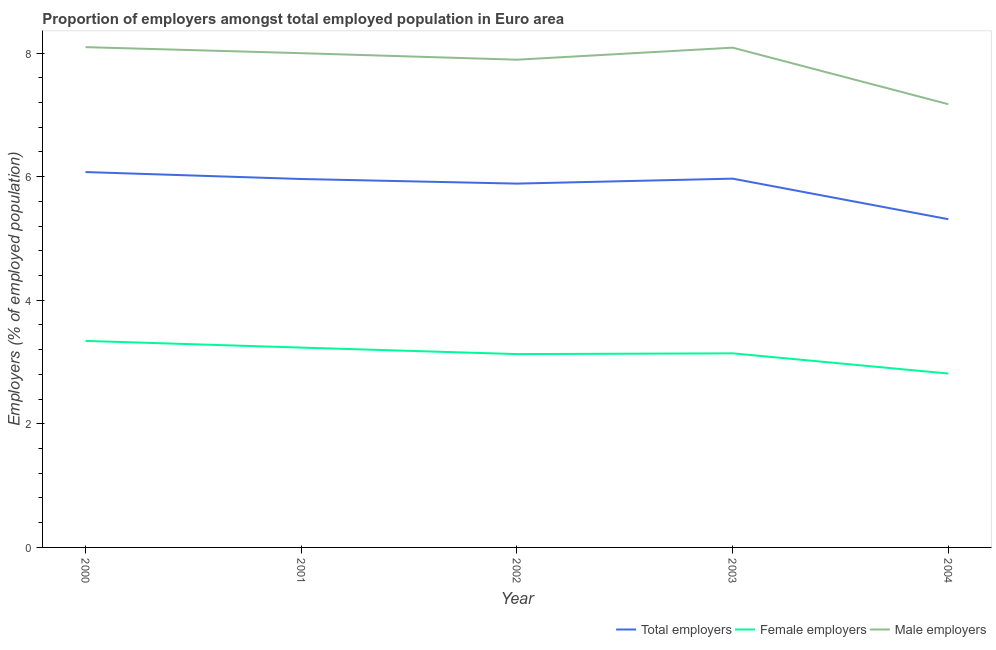How many different coloured lines are there?
Give a very brief answer. 3. Is the number of lines equal to the number of legend labels?
Make the answer very short. Yes. What is the percentage of male employers in 2001?
Offer a very short reply. 8. Across all years, what is the maximum percentage of male employers?
Ensure brevity in your answer.  8.1. Across all years, what is the minimum percentage of female employers?
Keep it short and to the point. 2.81. What is the total percentage of female employers in the graph?
Ensure brevity in your answer.  15.66. What is the difference between the percentage of total employers in 2001 and that in 2002?
Keep it short and to the point. 0.07. What is the difference between the percentage of male employers in 2001 and the percentage of female employers in 2003?
Your answer should be compact. 4.86. What is the average percentage of male employers per year?
Offer a terse response. 7.85. In the year 2004, what is the difference between the percentage of male employers and percentage of female employers?
Keep it short and to the point. 4.36. In how many years, is the percentage of male employers greater than 0.8 %?
Your answer should be compact. 5. What is the ratio of the percentage of total employers in 2000 to that in 2002?
Offer a very short reply. 1.03. Is the difference between the percentage of total employers in 2000 and 2002 greater than the difference between the percentage of female employers in 2000 and 2002?
Provide a short and direct response. No. What is the difference between the highest and the second highest percentage of total employers?
Provide a short and direct response. 0.11. What is the difference between the highest and the lowest percentage of male employers?
Your answer should be compact. 0.92. In how many years, is the percentage of male employers greater than the average percentage of male employers taken over all years?
Provide a succinct answer. 4. Is the percentage of total employers strictly greater than the percentage of male employers over the years?
Ensure brevity in your answer.  No. How many lines are there?
Your response must be concise. 3. How many years are there in the graph?
Offer a very short reply. 5. What is the difference between two consecutive major ticks on the Y-axis?
Offer a very short reply. 2. Are the values on the major ticks of Y-axis written in scientific E-notation?
Give a very brief answer. No. Does the graph contain any zero values?
Keep it short and to the point. No. How are the legend labels stacked?
Your response must be concise. Horizontal. What is the title of the graph?
Offer a very short reply. Proportion of employers amongst total employed population in Euro area. What is the label or title of the X-axis?
Give a very brief answer. Year. What is the label or title of the Y-axis?
Provide a short and direct response. Employers (% of employed population). What is the Employers (% of employed population) of Total employers in 2000?
Offer a terse response. 6.07. What is the Employers (% of employed population) in Female employers in 2000?
Your answer should be compact. 3.34. What is the Employers (% of employed population) in Male employers in 2000?
Offer a very short reply. 8.1. What is the Employers (% of employed population) of Total employers in 2001?
Offer a terse response. 5.96. What is the Employers (% of employed population) in Female employers in 2001?
Ensure brevity in your answer.  3.23. What is the Employers (% of employed population) of Male employers in 2001?
Offer a terse response. 8. What is the Employers (% of employed population) of Total employers in 2002?
Offer a very short reply. 5.89. What is the Employers (% of employed population) of Female employers in 2002?
Your answer should be compact. 3.13. What is the Employers (% of employed population) in Male employers in 2002?
Make the answer very short. 7.89. What is the Employers (% of employed population) in Total employers in 2003?
Offer a very short reply. 5.97. What is the Employers (% of employed population) of Female employers in 2003?
Give a very brief answer. 3.14. What is the Employers (% of employed population) in Male employers in 2003?
Offer a terse response. 8.09. What is the Employers (% of employed population) in Total employers in 2004?
Give a very brief answer. 5.31. What is the Employers (% of employed population) of Female employers in 2004?
Offer a very short reply. 2.81. What is the Employers (% of employed population) of Male employers in 2004?
Your answer should be compact. 7.17. Across all years, what is the maximum Employers (% of employed population) of Total employers?
Make the answer very short. 6.07. Across all years, what is the maximum Employers (% of employed population) of Female employers?
Your answer should be very brief. 3.34. Across all years, what is the maximum Employers (% of employed population) of Male employers?
Give a very brief answer. 8.1. Across all years, what is the minimum Employers (% of employed population) of Total employers?
Make the answer very short. 5.31. Across all years, what is the minimum Employers (% of employed population) in Female employers?
Give a very brief answer. 2.81. Across all years, what is the minimum Employers (% of employed population) of Male employers?
Make the answer very short. 7.17. What is the total Employers (% of employed population) in Total employers in the graph?
Your response must be concise. 29.2. What is the total Employers (% of employed population) in Female employers in the graph?
Offer a terse response. 15.66. What is the total Employers (% of employed population) of Male employers in the graph?
Keep it short and to the point. 39.25. What is the difference between the Employers (% of employed population) of Total employers in 2000 and that in 2001?
Keep it short and to the point. 0.11. What is the difference between the Employers (% of employed population) in Female employers in 2000 and that in 2001?
Your answer should be compact. 0.11. What is the difference between the Employers (% of employed population) of Male employers in 2000 and that in 2001?
Offer a terse response. 0.1. What is the difference between the Employers (% of employed population) in Total employers in 2000 and that in 2002?
Keep it short and to the point. 0.19. What is the difference between the Employers (% of employed population) of Female employers in 2000 and that in 2002?
Offer a very short reply. 0.21. What is the difference between the Employers (% of employed population) in Male employers in 2000 and that in 2002?
Provide a short and direct response. 0.2. What is the difference between the Employers (% of employed population) in Total employers in 2000 and that in 2003?
Keep it short and to the point. 0.11. What is the difference between the Employers (% of employed population) in Female employers in 2000 and that in 2003?
Give a very brief answer. 0.2. What is the difference between the Employers (% of employed population) in Male employers in 2000 and that in 2003?
Your answer should be very brief. 0.01. What is the difference between the Employers (% of employed population) of Total employers in 2000 and that in 2004?
Make the answer very short. 0.76. What is the difference between the Employers (% of employed population) of Female employers in 2000 and that in 2004?
Your answer should be compact. 0.53. What is the difference between the Employers (% of employed population) of Male employers in 2000 and that in 2004?
Make the answer very short. 0.92. What is the difference between the Employers (% of employed population) of Total employers in 2001 and that in 2002?
Provide a short and direct response. 0.07. What is the difference between the Employers (% of employed population) of Female employers in 2001 and that in 2002?
Provide a succinct answer. 0.11. What is the difference between the Employers (% of employed population) in Male employers in 2001 and that in 2002?
Offer a very short reply. 0.11. What is the difference between the Employers (% of employed population) of Total employers in 2001 and that in 2003?
Your answer should be compact. -0.01. What is the difference between the Employers (% of employed population) of Female employers in 2001 and that in 2003?
Make the answer very short. 0.09. What is the difference between the Employers (% of employed population) of Male employers in 2001 and that in 2003?
Keep it short and to the point. -0.09. What is the difference between the Employers (% of employed population) in Total employers in 2001 and that in 2004?
Keep it short and to the point. 0.65. What is the difference between the Employers (% of employed population) of Female employers in 2001 and that in 2004?
Make the answer very short. 0.42. What is the difference between the Employers (% of employed population) in Male employers in 2001 and that in 2004?
Offer a very short reply. 0.83. What is the difference between the Employers (% of employed population) in Total employers in 2002 and that in 2003?
Offer a terse response. -0.08. What is the difference between the Employers (% of employed population) in Female employers in 2002 and that in 2003?
Provide a short and direct response. -0.01. What is the difference between the Employers (% of employed population) of Male employers in 2002 and that in 2003?
Offer a very short reply. -0.19. What is the difference between the Employers (% of employed population) in Total employers in 2002 and that in 2004?
Keep it short and to the point. 0.58. What is the difference between the Employers (% of employed population) of Female employers in 2002 and that in 2004?
Your response must be concise. 0.31. What is the difference between the Employers (% of employed population) in Male employers in 2002 and that in 2004?
Give a very brief answer. 0.72. What is the difference between the Employers (% of employed population) in Total employers in 2003 and that in 2004?
Provide a succinct answer. 0.66. What is the difference between the Employers (% of employed population) in Female employers in 2003 and that in 2004?
Your answer should be very brief. 0.33. What is the difference between the Employers (% of employed population) in Male employers in 2003 and that in 2004?
Keep it short and to the point. 0.92. What is the difference between the Employers (% of employed population) of Total employers in 2000 and the Employers (% of employed population) of Female employers in 2001?
Ensure brevity in your answer.  2.84. What is the difference between the Employers (% of employed population) of Total employers in 2000 and the Employers (% of employed population) of Male employers in 2001?
Your answer should be very brief. -1.92. What is the difference between the Employers (% of employed population) in Female employers in 2000 and the Employers (% of employed population) in Male employers in 2001?
Offer a very short reply. -4.66. What is the difference between the Employers (% of employed population) of Total employers in 2000 and the Employers (% of employed population) of Female employers in 2002?
Your response must be concise. 2.95. What is the difference between the Employers (% of employed population) of Total employers in 2000 and the Employers (% of employed population) of Male employers in 2002?
Keep it short and to the point. -1.82. What is the difference between the Employers (% of employed population) of Female employers in 2000 and the Employers (% of employed population) of Male employers in 2002?
Make the answer very short. -4.55. What is the difference between the Employers (% of employed population) in Total employers in 2000 and the Employers (% of employed population) in Female employers in 2003?
Your answer should be compact. 2.93. What is the difference between the Employers (% of employed population) in Total employers in 2000 and the Employers (% of employed population) in Male employers in 2003?
Provide a short and direct response. -2.01. What is the difference between the Employers (% of employed population) of Female employers in 2000 and the Employers (% of employed population) of Male employers in 2003?
Offer a very short reply. -4.75. What is the difference between the Employers (% of employed population) in Total employers in 2000 and the Employers (% of employed population) in Female employers in 2004?
Offer a terse response. 3.26. What is the difference between the Employers (% of employed population) of Total employers in 2000 and the Employers (% of employed population) of Male employers in 2004?
Your answer should be very brief. -1.1. What is the difference between the Employers (% of employed population) in Female employers in 2000 and the Employers (% of employed population) in Male employers in 2004?
Provide a succinct answer. -3.83. What is the difference between the Employers (% of employed population) in Total employers in 2001 and the Employers (% of employed population) in Female employers in 2002?
Your response must be concise. 2.83. What is the difference between the Employers (% of employed population) of Total employers in 2001 and the Employers (% of employed population) of Male employers in 2002?
Ensure brevity in your answer.  -1.93. What is the difference between the Employers (% of employed population) of Female employers in 2001 and the Employers (% of employed population) of Male employers in 2002?
Your answer should be compact. -4.66. What is the difference between the Employers (% of employed population) of Total employers in 2001 and the Employers (% of employed population) of Female employers in 2003?
Provide a succinct answer. 2.82. What is the difference between the Employers (% of employed population) of Total employers in 2001 and the Employers (% of employed population) of Male employers in 2003?
Your response must be concise. -2.13. What is the difference between the Employers (% of employed population) of Female employers in 2001 and the Employers (% of employed population) of Male employers in 2003?
Offer a terse response. -4.85. What is the difference between the Employers (% of employed population) of Total employers in 2001 and the Employers (% of employed population) of Female employers in 2004?
Give a very brief answer. 3.15. What is the difference between the Employers (% of employed population) of Total employers in 2001 and the Employers (% of employed population) of Male employers in 2004?
Provide a short and direct response. -1.21. What is the difference between the Employers (% of employed population) in Female employers in 2001 and the Employers (% of employed population) in Male employers in 2004?
Offer a terse response. -3.94. What is the difference between the Employers (% of employed population) of Total employers in 2002 and the Employers (% of employed population) of Female employers in 2003?
Provide a short and direct response. 2.75. What is the difference between the Employers (% of employed population) in Total employers in 2002 and the Employers (% of employed population) in Male employers in 2003?
Your answer should be compact. -2.2. What is the difference between the Employers (% of employed population) of Female employers in 2002 and the Employers (% of employed population) of Male employers in 2003?
Ensure brevity in your answer.  -4.96. What is the difference between the Employers (% of employed population) of Total employers in 2002 and the Employers (% of employed population) of Female employers in 2004?
Ensure brevity in your answer.  3.07. What is the difference between the Employers (% of employed population) in Total employers in 2002 and the Employers (% of employed population) in Male employers in 2004?
Give a very brief answer. -1.28. What is the difference between the Employers (% of employed population) of Female employers in 2002 and the Employers (% of employed population) of Male employers in 2004?
Offer a very short reply. -4.04. What is the difference between the Employers (% of employed population) in Total employers in 2003 and the Employers (% of employed population) in Female employers in 2004?
Offer a very short reply. 3.15. What is the difference between the Employers (% of employed population) in Total employers in 2003 and the Employers (% of employed population) in Male employers in 2004?
Your answer should be compact. -1.2. What is the difference between the Employers (% of employed population) in Female employers in 2003 and the Employers (% of employed population) in Male employers in 2004?
Make the answer very short. -4.03. What is the average Employers (% of employed population) of Total employers per year?
Keep it short and to the point. 5.84. What is the average Employers (% of employed population) of Female employers per year?
Your response must be concise. 3.13. What is the average Employers (% of employed population) of Male employers per year?
Give a very brief answer. 7.85. In the year 2000, what is the difference between the Employers (% of employed population) in Total employers and Employers (% of employed population) in Female employers?
Your answer should be compact. 2.73. In the year 2000, what is the difference between the Employers (% of employed population) in Total employers and Employers (% of employed population) in Male employers?
Make the answer very short. -2.02. In the year 2000, what is the difference between the Employers (% of employed population) of Female employers and Employers (% of employed population) of Male employers?
Provide a succinct answer. -4.75. In the year 2001, what is the difference between the Employers (% of employed population) of Total employers and Employers (% of employed population) of Female employers?
Offer a terse response. 2.73. In the year 2001, what is the difference between the Employers (% of employed population) in Total employers and Employers (% of employed population) in Male employers?
Your answer should be very brief. -2.04. In the year 2001, what is the difference between the Employers (% of employed population) of Female employers and Employers (% of employed population) of Male employers?
Offer a terse response. -4.76. In the year 2002, what is the difference between the Employers (% of employed population) of Total employers and Employers (% of employed population) of Female employers?
Provide a succinct answer. 2.76. In the year 2002, what is the difference between the Employers (% of employed population) of Total employers and Employers (% of employed population) of Male employers?
Your response must be concise. -2.01. In the year 2002, what is the difference between the Employers (% of employed population) of Female employers and Employers (% of employed population) of Male employers?
Keep it short and to the point. -4.76. In the year 2003, what is the difference between the Employers (% of employed population) in Total employers and Employers (% of employed population) in Female employers?
Your answer should be compact. 2.83. In the year 2003, what is the difference between the Employers (% of employed population) of Total employers and Employers (% of employed population) of Male employers?
Ensure brevity in your answer.  -2.12. In the year 2003, what is the difference between the Employers (% of employed population) in Female employers and Employers (% of employed population) in Male employers?
Keep it short and to the point. -4.95. In the year 2004, what is the difference between the Employers (% of employed population) of Total employers and Employers (% of employed population) of Female employers?
Offer a very short reply. 2.5. In the year 2004, what is the difference between the Employers (% of employed population) of Total employers and Employers (% of employed population) of Male employers?
Ensure brevity in your answer.  -1.86. In the year 2004, what is the difference between the Employers (% of employed population) of Female employers and Employers (% of employed population) of Male employers?
Provide a succinct answer. -4.36. What is the ratio of the Employers (% of employed population) of Total employers in 2000 to that in 2001?
Your answer should be compact. 1.02. What is the ratio of the Employers (% of employed population) in Female employers in 2000 to that in 2001?
Ensure brevity in your answer.  1.03. What is the ratio of the Employers (% of employed population) of Male employers in 2000 to that in 2001?
Ensure brevity in your answer.  1.01. What is the ratio of the Employers (% of employed population) of Total employers in 2000 to that in 2002?
Give a very brief answer. 1.03. What is the ratio of the Employers (% of employed population) in Female employers in 2000 to that in 2002?
Your response must be concise. 1.07. What is the ratio of the Employers (% of employed population) in Male employers in 2000 to that in 2002?
Make the answer very short. 1.03. What is the ratio of the Employers (% of employed population) in Total employers in 2000 to that in 2003?
Offer a very short reply. 1.02. What is the ratio of the Employers (% of employed population) of Female employers in 2000 to that in 2003?
Provide a short and direct response. 1.06. What is the ratio of the Employers (% of employed population) of Male employers in 2000 to that in 2003?
Provide a short and direct response. 1. What is the ratio of the Employers (% of employed population) of Total employers in 2000 to that in 2004?
Provide a short and direct response. 1.14. What is the ratio of the Employers (% of employed population) in Female employers in 2000 to that in 2004?
Provide a succinct answer. 1.19. What is the ratio of the Employers (% of employed population) of Male employers in 2000 to that in 2004?
Your response must be concise. 1.13. What is the ratio of the Employers (% of employed population) in Total employers in 2001 to that in 2002?
Provide a short and direct response. 1.01. What is the ratio of the Employers (% of employed population) in Female employers in 2001 to that in 2002?
Keep it short and to the point. 1.03. What is the ratio of the Employers (% of employed population) of Male employers in 2001 to that in 2002?
Your response must be concise. 1.01. What is the ratio of the Employers (% of employed population) of Female employers in 2001 to that in 2003?
Provide a short and direct response. 1.03. What is the ratio of the Employers (% of employed population) of Male employers in 2001 to that in 2003?
Your answer should be compact. 0.99. What is the ratio of the Employers (% of employed population) of Total employers in 2001 to that in 2004?
Provide a short and direct response. 1.12. What is the ratio of the Employers (% of employed population) of Female employers in 2001 to that in 2004?
Your answer should be compact. 1.15. What is the ratio of the Employers (% of employed population) of Male employers in 2001 to that in 2004?
Your answer should be compact. 1.12. What is the ratio of the Employers (% of employed population) of Total employers in 2002 to that in 2003?
Ensure brevity in your answer.  0.99. What is the ratio of the Employers (% of employed population) of Male employers in 2002 to that in 2003?
Give a very brief answer. 0.98. What is the ratio of the Employers (% of employed population) in Total employers in 2002 to that in 2004?
Provide a short and direct response. 1.11. What is the ratio of the Employers (% of employed population) of Female employers in 2002 to that in 2004?
Provide a succinct answer. 1.11. What is the ratio of the Employers (% of employed population) in Male employers in 2002 to that in 2004?
Provide a succinct answer. 1.1. What is the ratio of the Employers (% of employed population) of Total employers in 2003 to that in 2004?
Provide a short and direct response. 1.12. What is the ratio of the Employers (% of employed population) of Female employers in 2003 to that in 2004?
Your response must be concise. 1.12. What is the ratio of the Employers (% of employed population) in Male employers in 2003 to that in 2004?
Make the answer very short. 1.13. What is the difference between the highest and the second highest Employers (% of employed population) in Total employers?
Provide a short and direct response. 0.11. What is the difference between the highest and the second highest Employers (% of employed population) in Female employers?
Give a very brief answer. 0.11. What is the difference between the highest and the second highest Employers (% of employed population) in Male employers?
Provide a succinct answer. 0.01. What is the difference between the highest and the lowest Employers (% of employed population) of Total employers?
Offer a very short reply. 0.76. What is the difference between the highest and the lowest Employers (% of employed population) of Female employers?
Offer a terse response. 0.53. What is the difference between the highest and the lowest Employers (% of employed population) in Male employers?
Your answer should be compact. 0.92. 